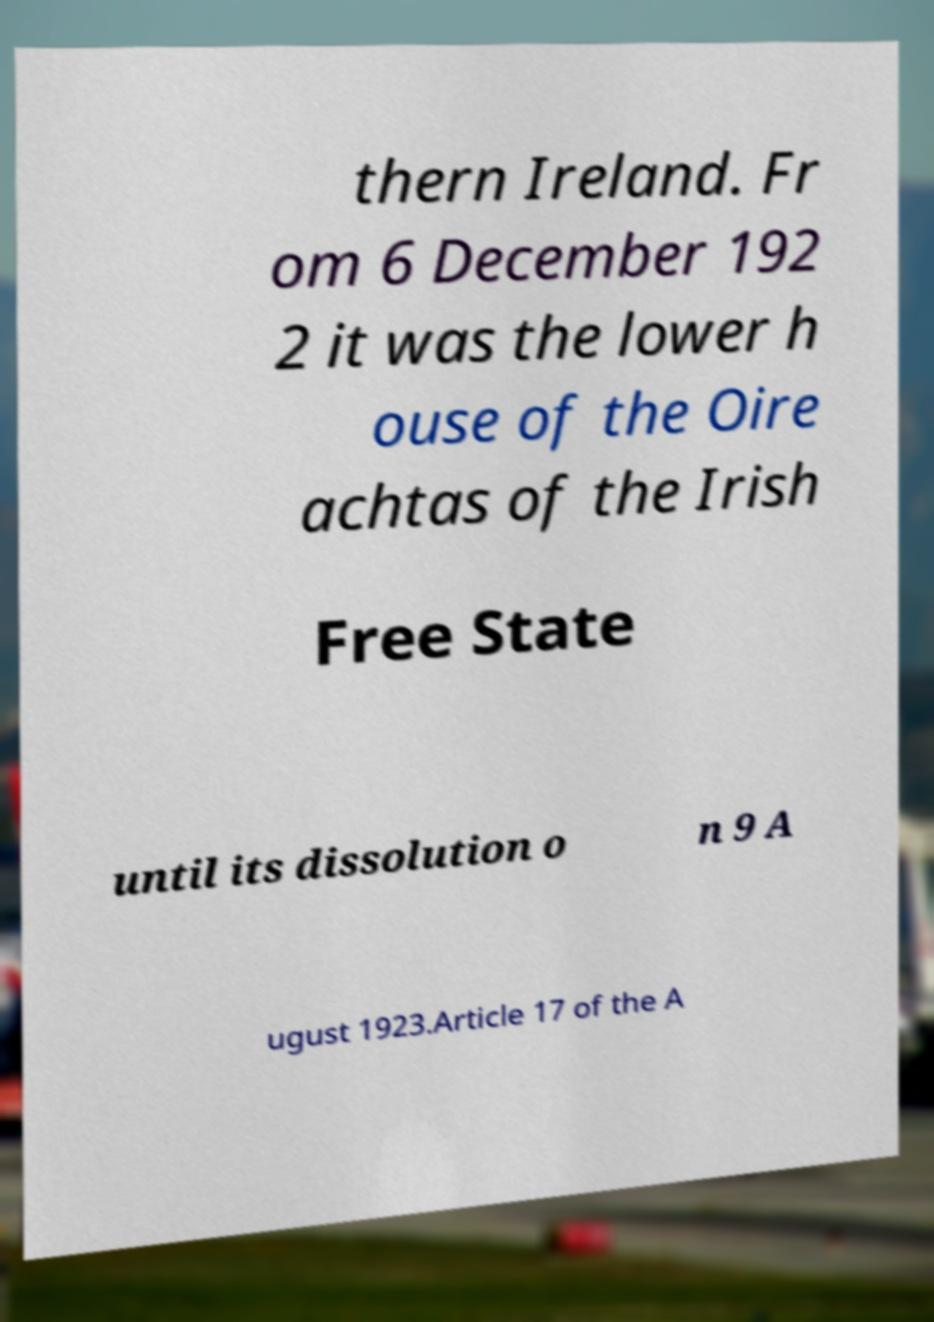For documentation purposes, I need the text within this image transcribed. Could you provide that? thern Ireland. Fr om 6 December 192 2 it was the lower h ouse of the Oire achtas of the Irish Free State until its dissolution o n 9 A ugust 1923.Article 17 of the A 